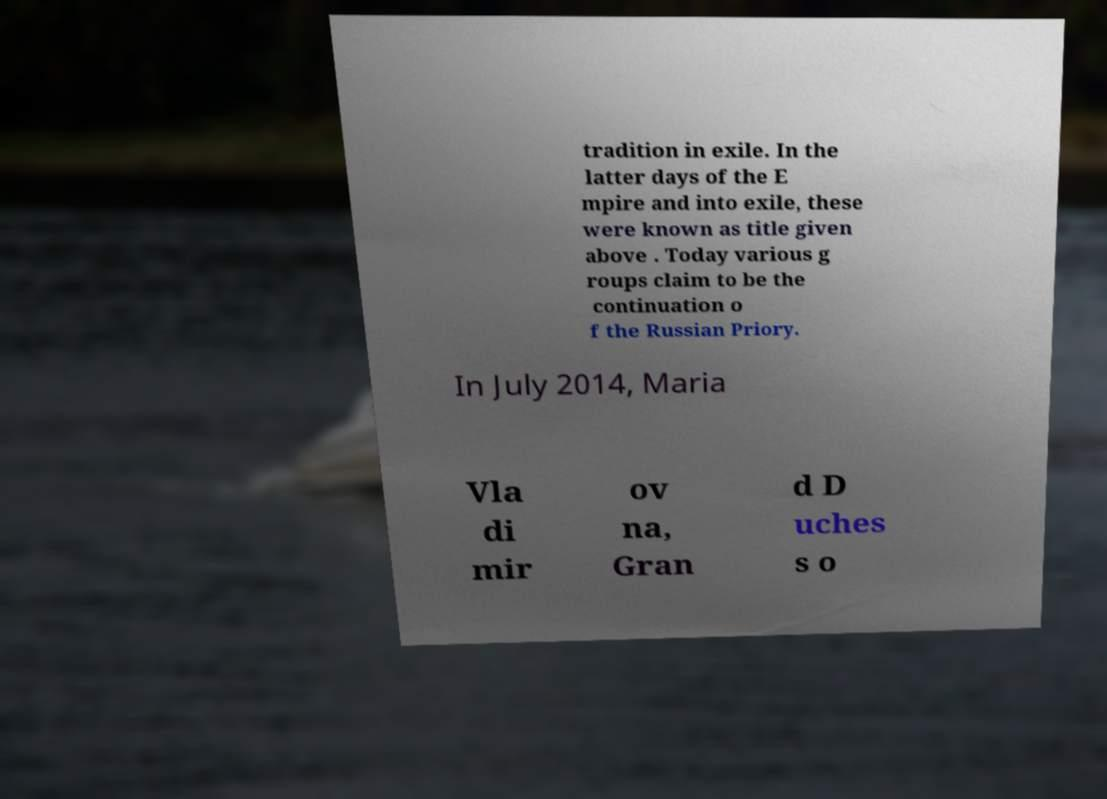Can you accurately transcribe the text from the provided image for me? tradition in exile. In the latter days of the E mpire and into exile, these were known as title given above . Today various g roups claim to be the continuation o f the Russian Priory. In July 2014, Maria Vla di mir ov na, Gran d D uches s o 